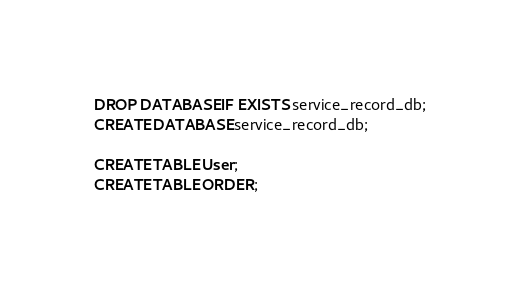Convert code to text. <code><loc_0><loc_0><loc_500><loc_500><_SQL_>DROP DATABASE IF EXISTS service_record_db;
CREATE DATABASE service_record_db;

CREATE TABLE User;
CREATE TABLE ORDER;</code> 